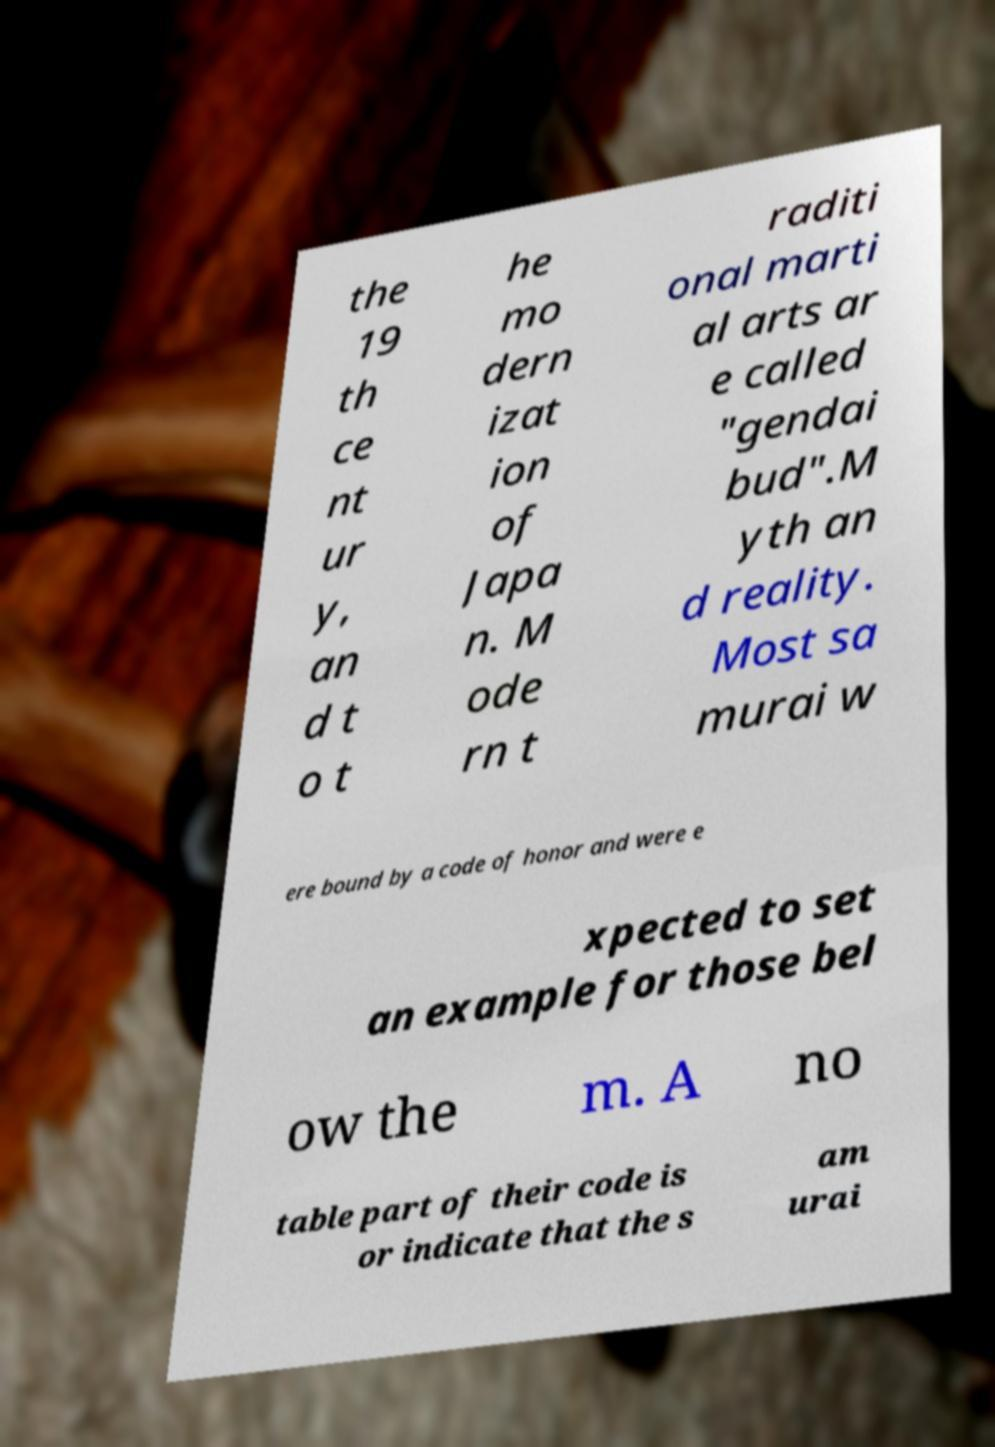There's text embedded in this image that I need extracted. Can you transcribe it verbatim? the 19 th ce nt ur y, an d t o t he mo dern izat ion of Japa n. M ode rn t raditi onal marti al arts ar e called "gendai bud".M yth an d reality. Most sa murai w ere bound by a code of honor and were e xpected to set an example for those bel ow the m. A no table part of their code is or indicate that the s am urai 